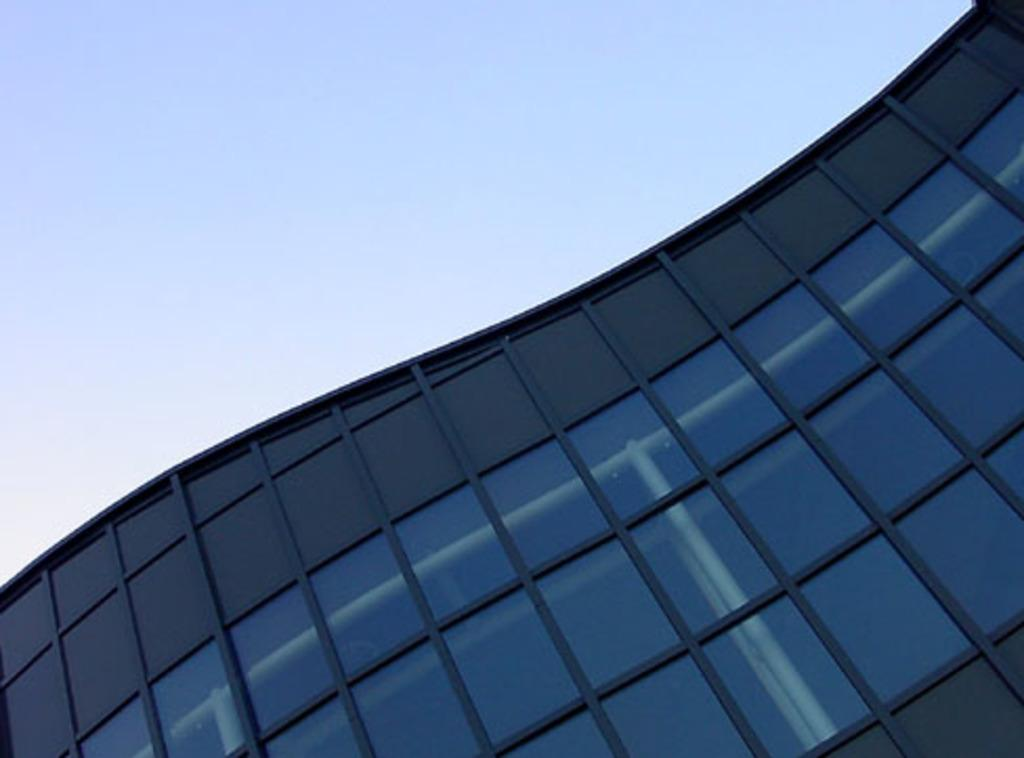What type of structure is in the picture? There is a building in the picture. What feature can be observed on the building? The building has glass windows. What is the condition of the sky in the picture? The sky is clear in the picture. How does the building transport people to different floors? The image does not show any specific transportation method within the building, such as an elevator or stairs. --- Facts: 1. There is a person holding a book in the image. 2. The person is sitting on a chair. 3. There is a table next to the chair. 4. The book has a blue cover. Absurd Topics: dance, swim, fly Conversation: What is the person in the image holding? The person is holding a book in the image. What is the person's position in the image? The person is sitting on a chair. What is located next to the chair? There is a table next to the chair. What color is the book's cover? The book has a blue cover. Reasoning: Let's think step by step in order to produce the conversation. We start by identifying the main subject of the image, which is the person holding a book. Next, we describe the person's position, which is sitting on a chair. Then, we mention the presence of a table next to the chair. Finally, we provide a detail about the book, which is its blue cover. Absurd Question/Answer: How does the person in the image dance while holding the book? The image does not show the person dancing; they are sitting on a chair and holding a book. 